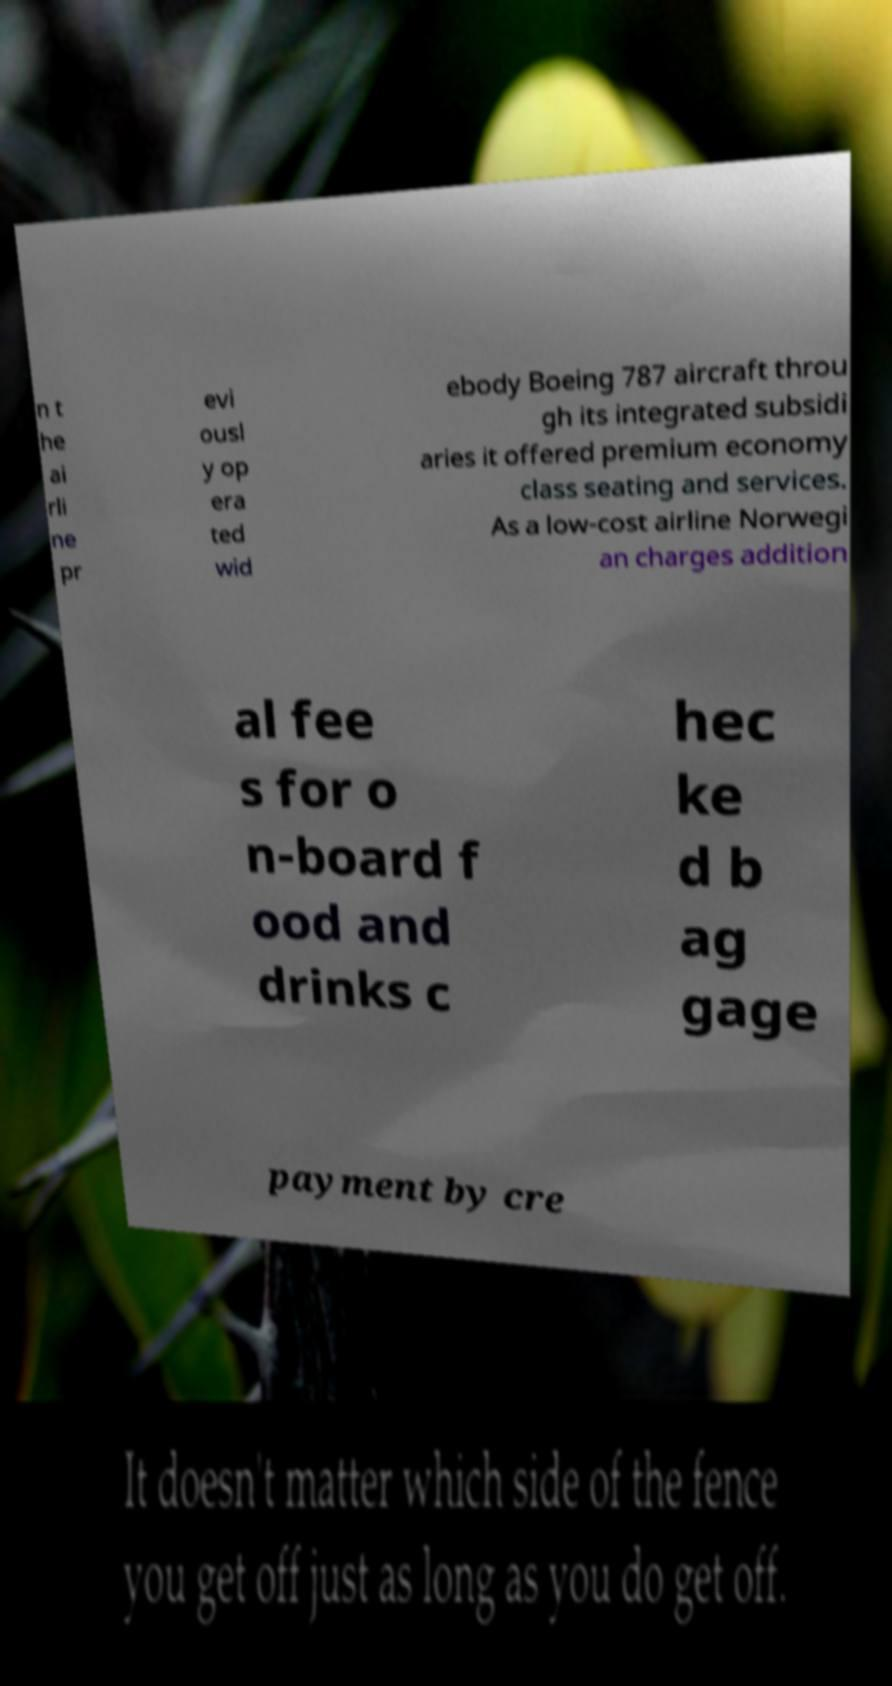Can you accurately transcribe the text from the provided image for me? n t he ai rli ne pr evi ousl y op era ted wid ebody Boeing 787 aircraft throu gh its integrated subsidi aries it offered premium economy class seating and services. As a low-cost airline Norwegi an charges addition al fee s for o n-board f ood and drinks c hec ke d b ag gage payment by cre 